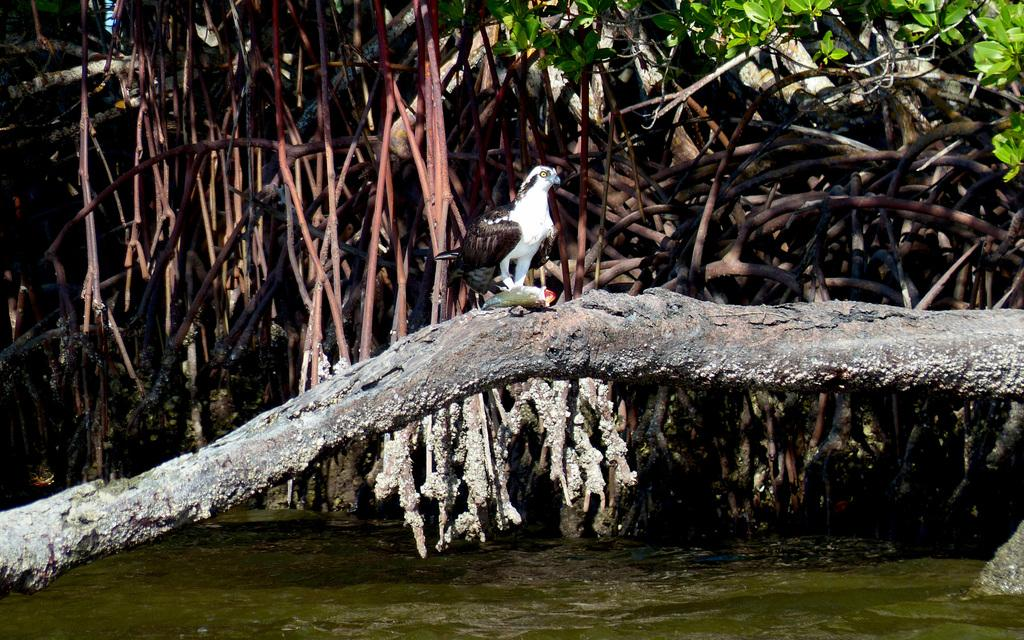What is on the wooden surface in the image? There is a bird on a wooden surface in the image. What can be seen in the image besides the bird and wooden surface? There is water visible in the image. What type of tree can be seen in the background of the image? There is a banyan tree in the background of the image. What color are the leaves in the background of the image? Green leaves are present in the background. How many toes does the bird have in the image? Birds do not have toes in the same way that mammals do, so it is not possible to count toes on a bird in the image. 